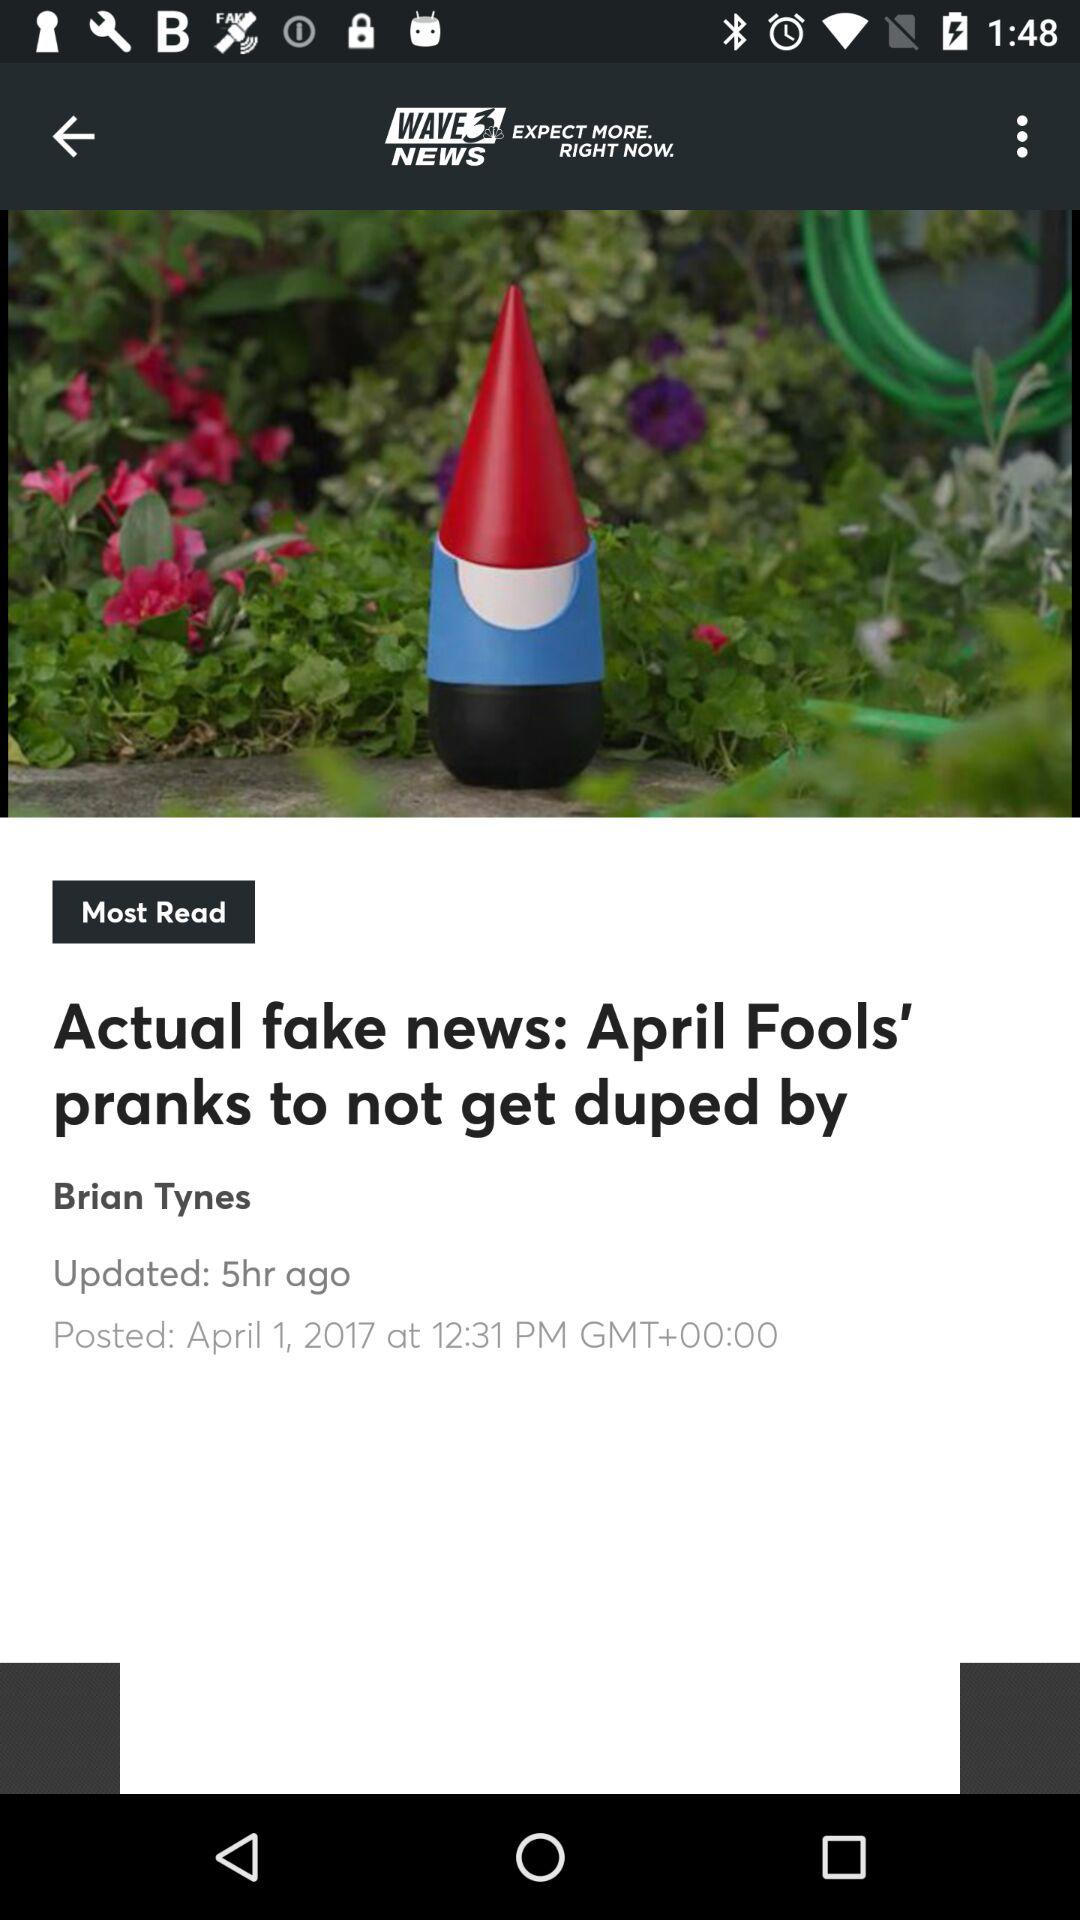When was the article updated? The article was updated 5 hours ago. 